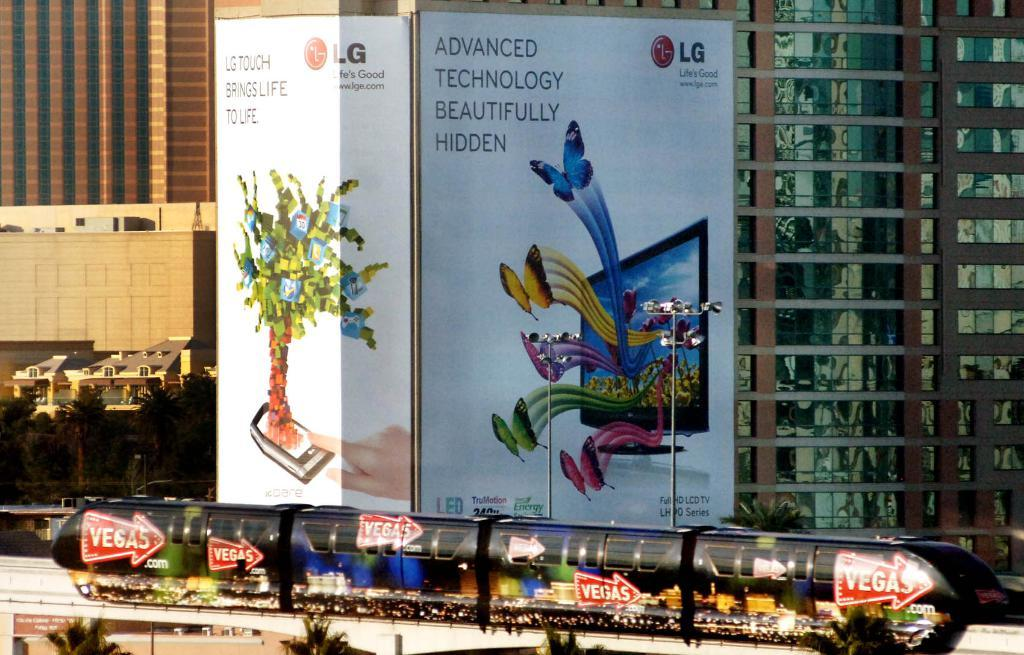<image>
Render a clear and concise summary of the photo. A white billboard that has a tv that says LG on it. 